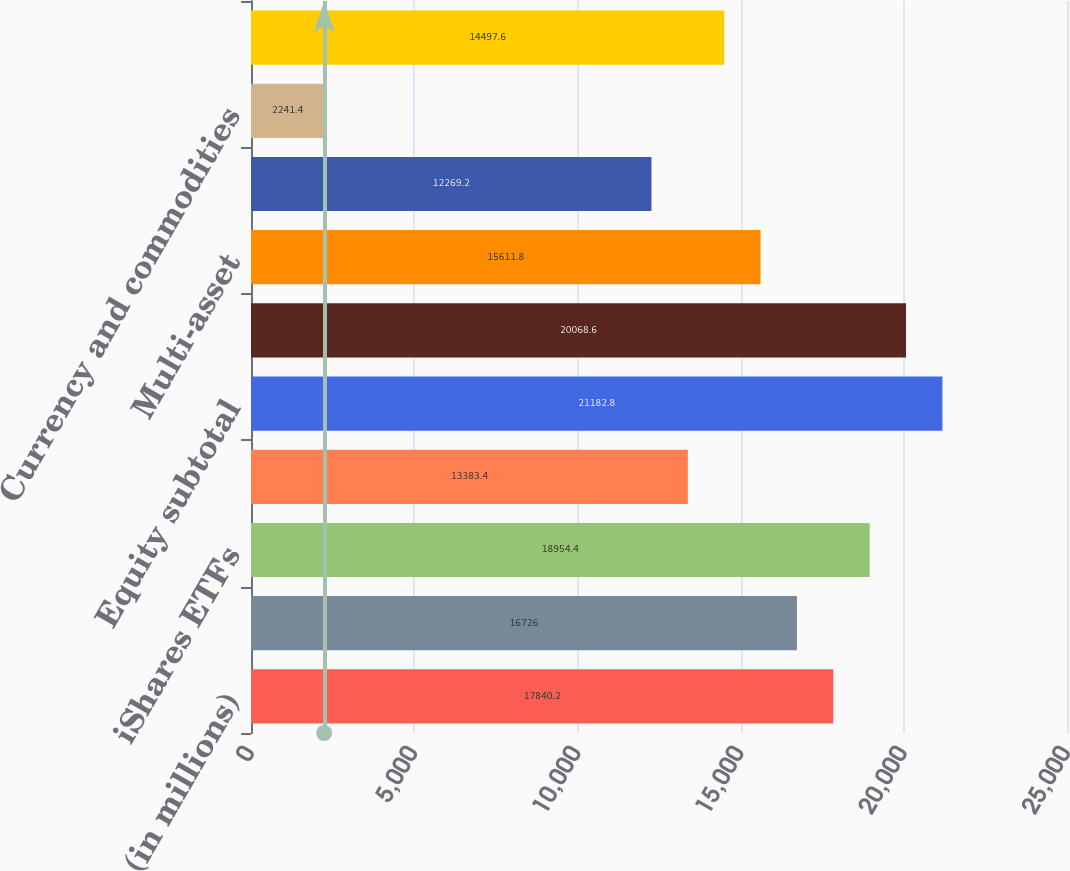Convert chart. <chart><loc_0><loc_0><loc_500><loc_500><bar_chart><fcel>(in millions)<fcel>Active<fcel>iShares ETFs<fcel>Non-ETF index<fcel>Equity subtotal<fcel>Fixed income subtotal<fcel>Multi-asset<fcel>Core<fcel>Currency and commodities<fcel>Alternatives subtotal<nl><fcel>17840.2<fcel>16726<fcel>18954.4<fcel>13383.4<fcel>21182.8<fcel>20068.6<fcel>15611.8<fcel>12269.2<fcel>2241.4<fcel>14497.6<nl></chart> 